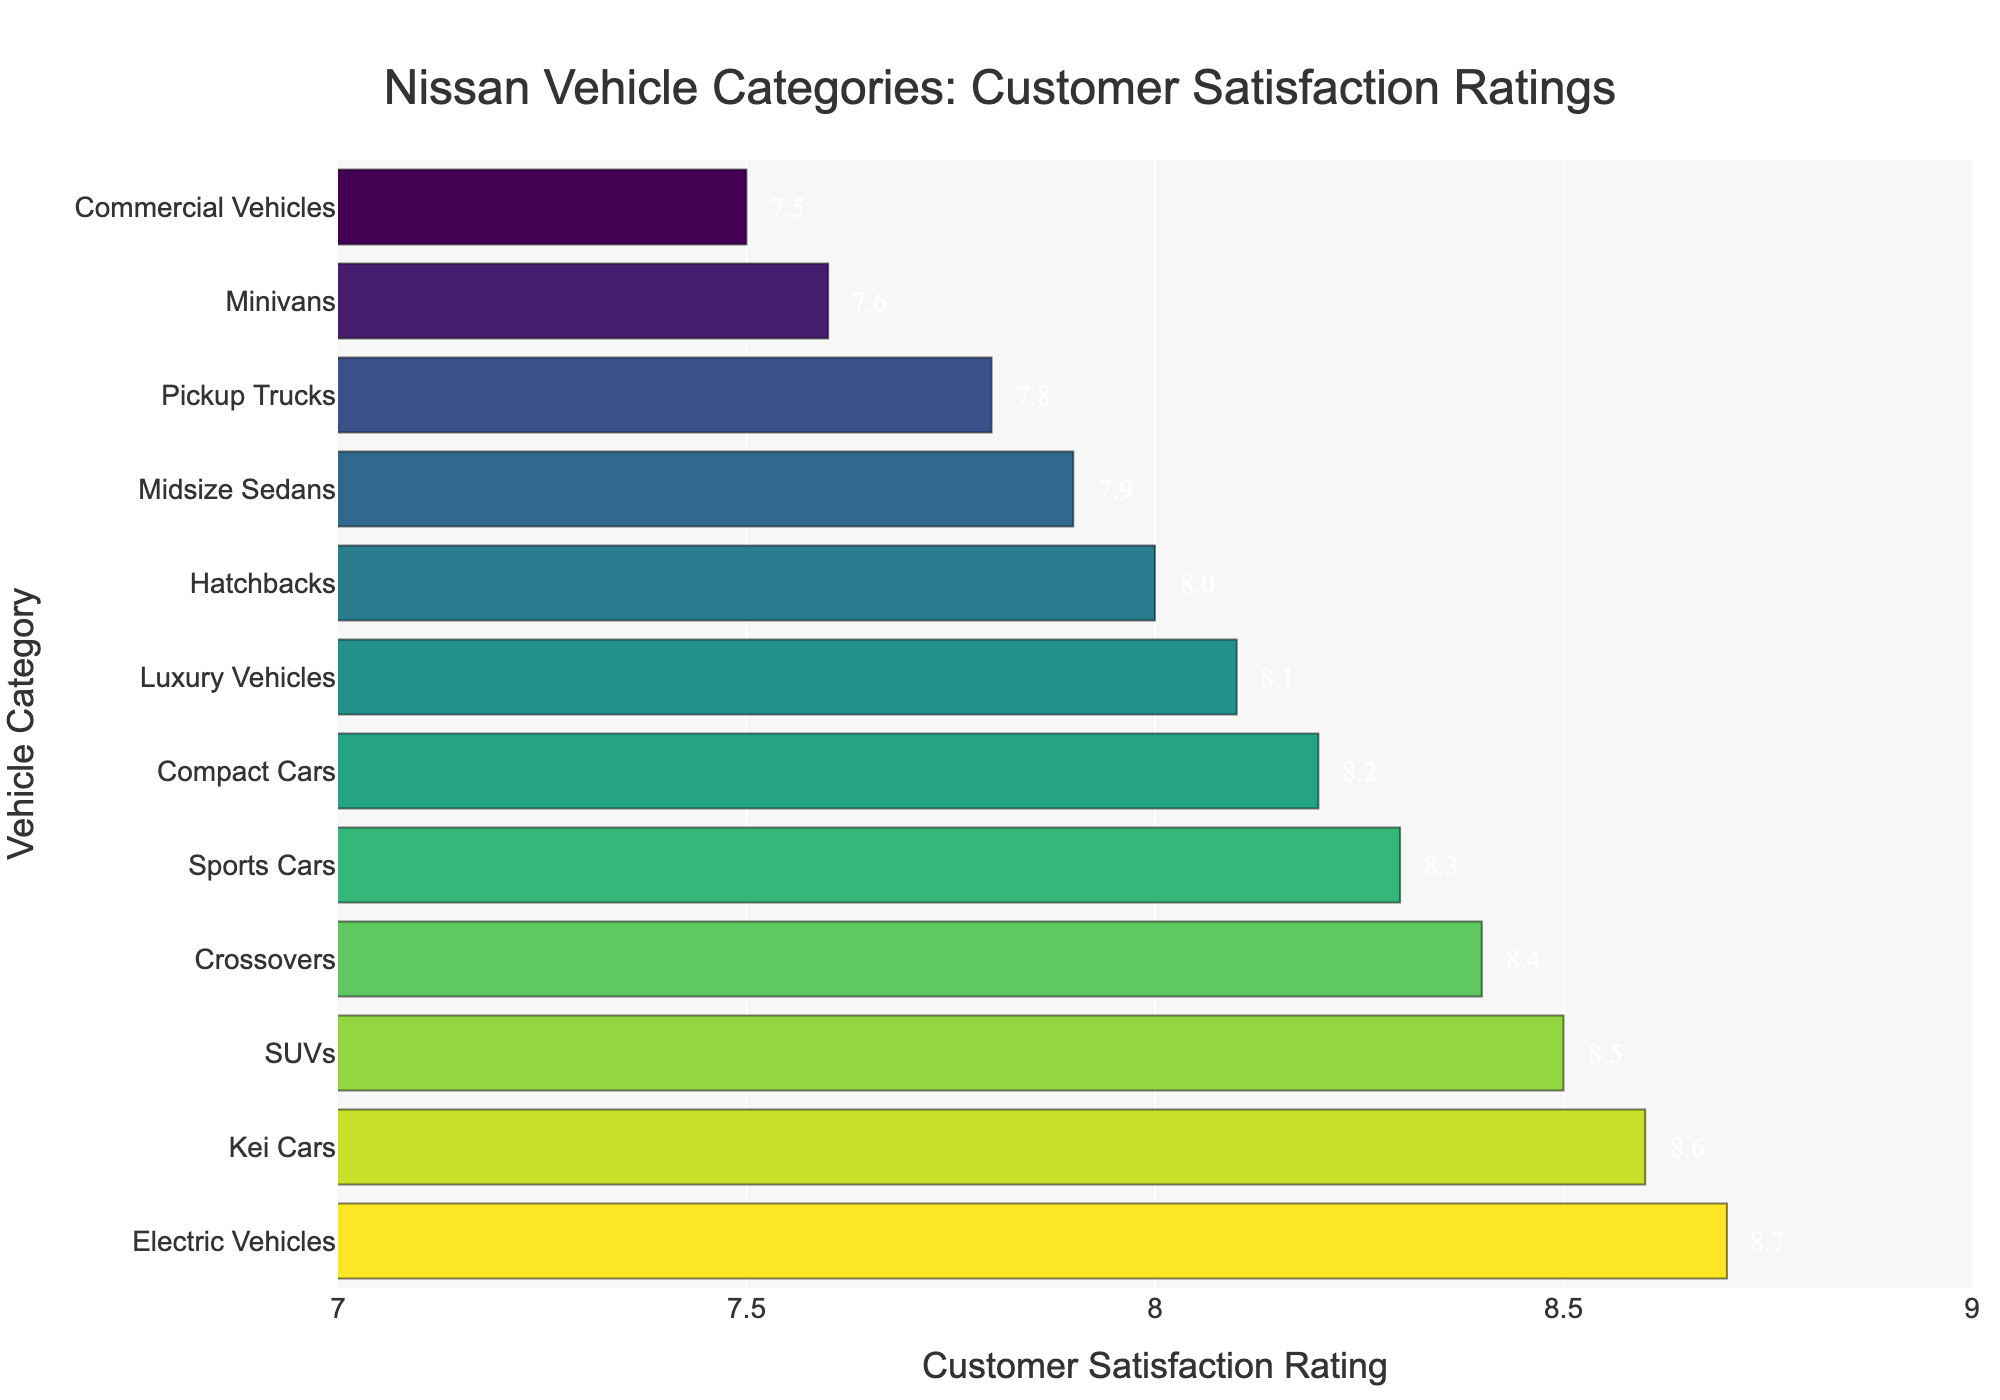Which Nissan vehicle category has the highest customer satisfaction rating? By looking at the top of the bar chart, we can see which category has the highest value on the x-axis.
Answer: Electric Vehicles Which Nissan vehicle category has the lowest customer satisfaction rating? By looking at the bottom of the bar chart, we can identify the category with the lowest value on the x-axis.
Answer: Commercial Vehicles What's the difference in customer satisfaction between Electric Vehicles and Commercial Vehicles? The satisfaction rating for Electric Vehicles is 8.7, and for Commercial Vehicles is 7.5. Subtract the two values: 8.7 - 7.5.
Answer: 1.2 Which vehicle categories have a customer satisfaction rating above 8.0? Identify all the bars with ratings that are greater than 8.0 by visually inspecting the x-axis values.
Answer: Compact Cars, SUVs, Electric Vehicles, Sports Cars, Luxury Vehicles, Crossovers, Kei Cars How does the customer satisfaction rating of Minivans compare to that of Pickup Trucks? Look at the ratings for Minivans and Pickup Trucks, which are 7.6 and 7.8 respectively. Compare the two values directly.
Answer: Pickup Trucks have a higher rating than Minivans What's the average customer satisfaction rating for the top 3 vehicle categories? The top 3 categories are Electric Vehicles, Kei Cars, and SUVs with ratings of 8.7, 8.6, and 8.5 respectively. The average is calculated as (8.7 + 8.6 + 8.5) / 3.
Answer: 8.6 Are there more vehicle categories with ratings above 8.0 or below 8.0? Count the number of categories with ratings above and below 8.0 by visually inspecting the chart. There are 7 categories above 8.0 and 5 categories below 8.0.
Answer: Above 8.0 Which category has a higher customer satisfaction rating: Hatchbacks or Midsize Sedans? Compare the ratings of Hatchbacks and Midsize Sedans, which are 8.0 and 7.9 respectively.
Answer: Hatchbacks What is the median customer satisfaction rating across all Nissan vehicle categories? First, list all ratings: 8.7, 8.6, 8.5, 8.4, 8.3, 8.2, 8.1, 8.0, 7.9, 7.8, 7.6, 7.5. With 12 categories, the median is the average of the 6th and 7th values in the sorted list: (8.2 + 8.1) / 2.
Answer: 8.15 Which visual attribute helps identify the highest-rated vehicle category most easily? The chart uses longer bars and a different shade of color to visually highlight higher ratings. The longest bar and the most intense color easily identify the highest-rated category.
Answer: Bar length and color intensity 